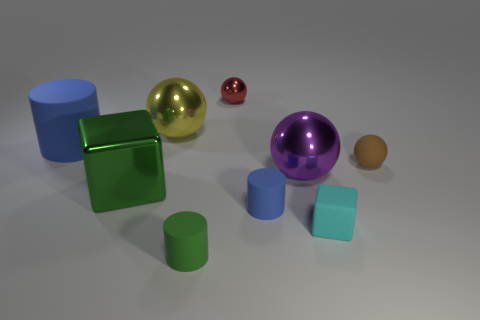Is the shape of the small green rubber thing the same as the small cyan matte object?
Offer a terse response. No. What is the green cylinder made of?
Keep it short and to the point. Rubber. What shape is the shiny thing that is right of the yellow shiny ball and in front of the large blue cylinder?
Provide a succinct answer. Sphere. There is a red ball that is made of the same material as the green block; what size is it?
Offer a very short reply. Small. There is a blue thing that is right of the large blue rubber object; how many blocks are behind it?
Keep it short and to the point. 1. Does the tiny thing on the right side of the rubber block have the same material as the big yellow sphere?
Provide a short and direct response. No. Is there anything else that has the same material as the cyan thing?
Offer a very short reply. Yes. What size is the matte cylinder that is on the left side of the matte thing in front of the tiny matte block?
Your response must be concise. Large. There is a blue thing in front of the metallic thing that is on the right side of the small ball that is left of the tiny cyan rubber cube; how big is it?
Offer a very short reply. Small. Do the brown thing that is right of the tiny green cylinder and the blue thing on the right side of the large blue object have the same shape?
Provide a succinct answer. No. 